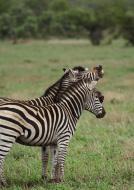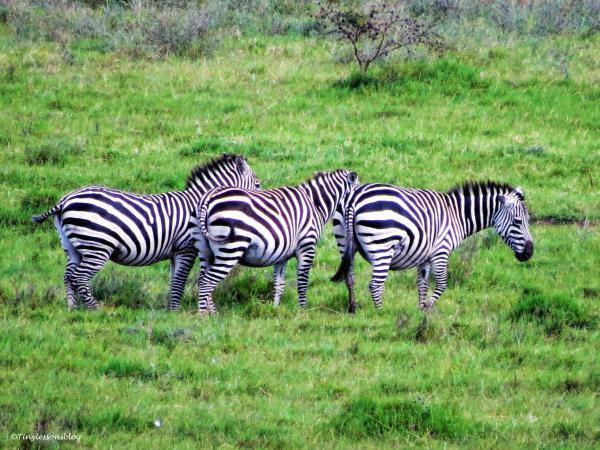The first image is the image on the left, the second image is the image on the right. Considering the images on both sides, is "The right image shows a lion attacking from the back end of a zebra, with clouds of dust created by the struggle." valid? Answer yes or no. No. The first image is the image on the left, the second image is the image on the right. Considering the images on both sides, is "The right image contains one zebras being attacked by a lion." valid? Answer yes or no. No. 